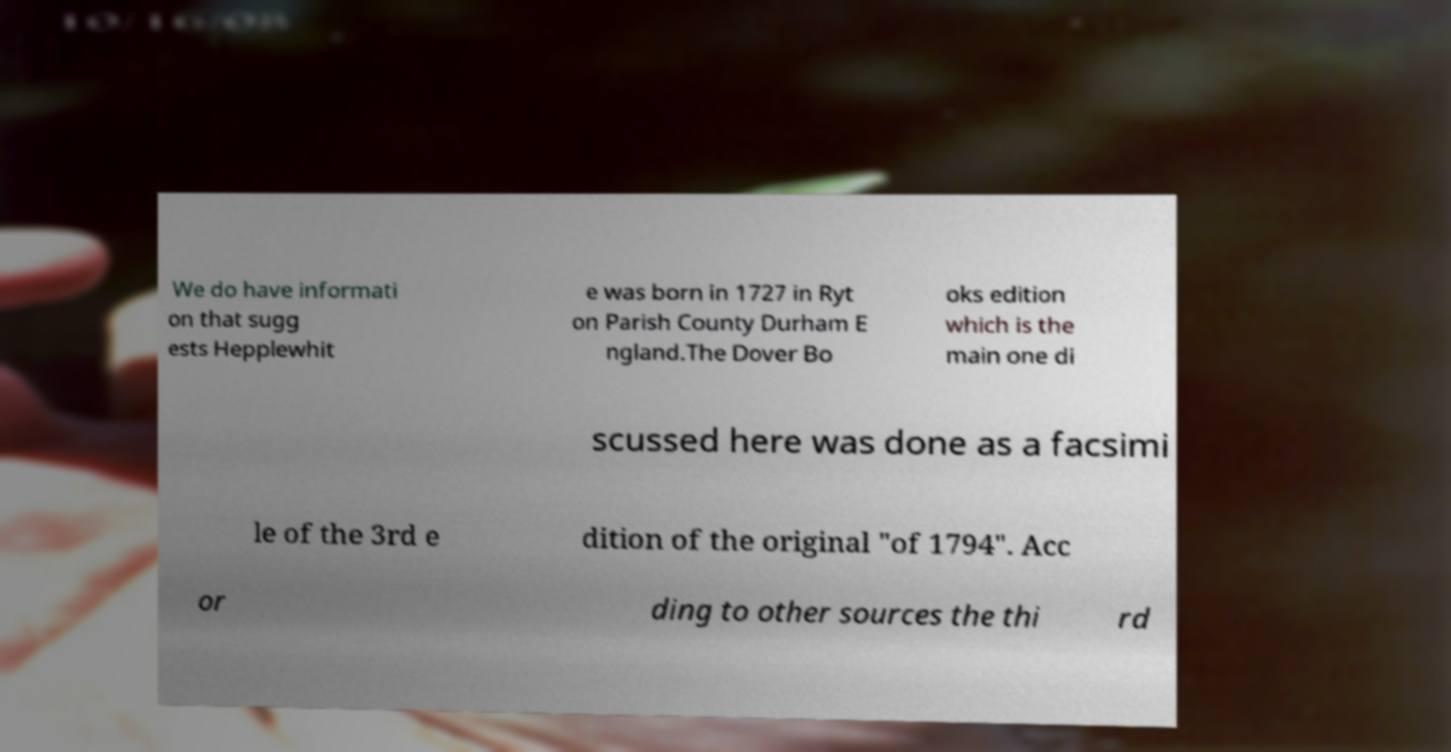Please read and relay the text visible in this image. What does it say? We do have informati on that sugg ests Hepplewhit e was born in 1727 in Ryt on Parish County Durham E ngland.The Dover Bo oks edition which is the main one di scussed here was done as a facsimi le of the 3rd e dition of the original "of 1794". Acc or ding to other sources the thi rd 